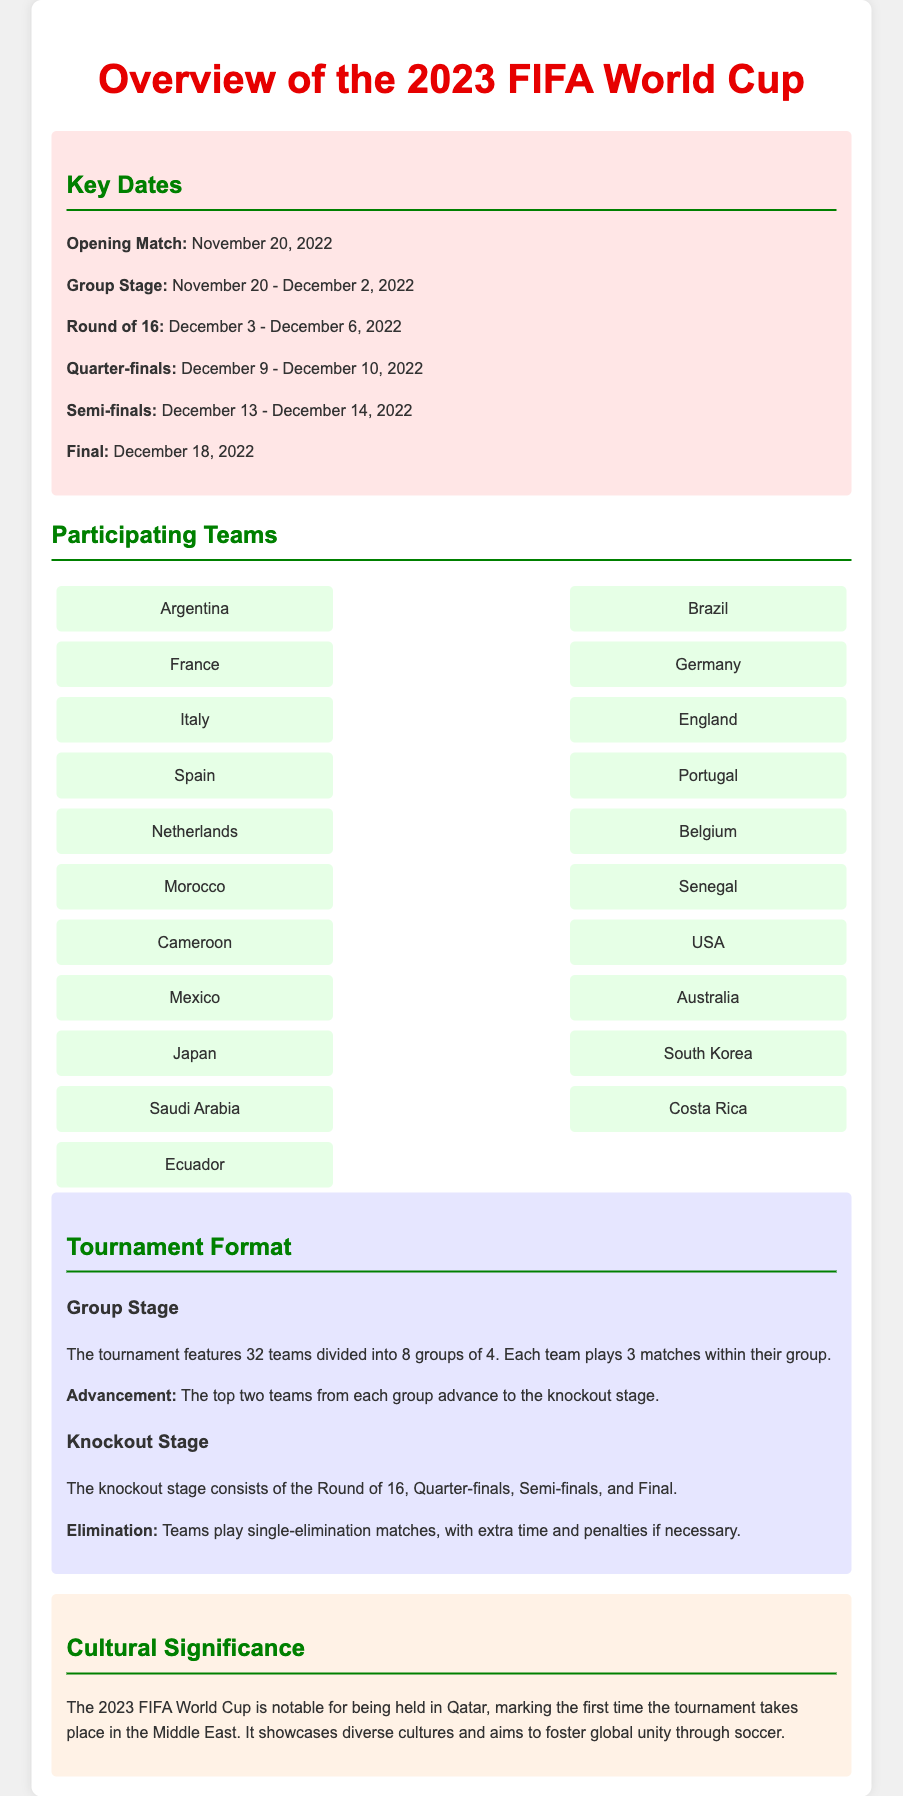what is the date of the opening match? The date of the opening match is provided in the "Key Dates" section of the document.
Answer: November 20, 2022 how many teams participate in the knockout stage? The knockout stage consists of 32 teams divided into groups, which allows the top teams to advance.
Answer: 32 teams what are the names of two African teams participating? The document specifically lists the teams, allowing identification of African teams.
Answer: Morocco, Cameroon how many groups are there in the group stage? The tournament format section specifies the number of groups within the group stage.
Answer: 8 groups what is the advancement criterion for knockout stage? The document explains that the top teams from each group move forward to the knockout stage.
Answer: Top two teams which team is listed first in the participating teams section? The teams are listed in a certain order in the document.
Answer: Argentina how many matches does each team play in the group stage? The tournament format details the number of matches each team engages in during the group stage.
Answer: 3 matches what is the date of the final match? The final match date is mentioned in the "Key Dates" section.
Answer: December 18, 2022 what kind of matches are played in the knockout stage? The document describes the match format for knockout, indicating the type of matches played.
Answer: Single-elimination matches 